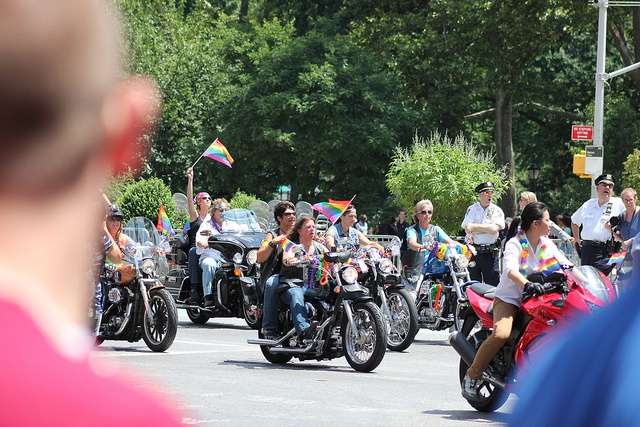Describe the objects in this image and their specific colors. I can see people in salmon, violet, lightpink, brown, and pink tones, motorcycle in salmon, black, brown, lightgray, and gray tones, motorcycle in salmon, black, gray, darkgray, and lightgray tones, people in salmon, black, darkgray, gray, and lightgray tones, and people in salmon, white, black, gray, and darkgray tones in this image. 